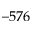<formula> <loc_0><loc_0><loc_500><loc_500>- 5 7 6</formula> 